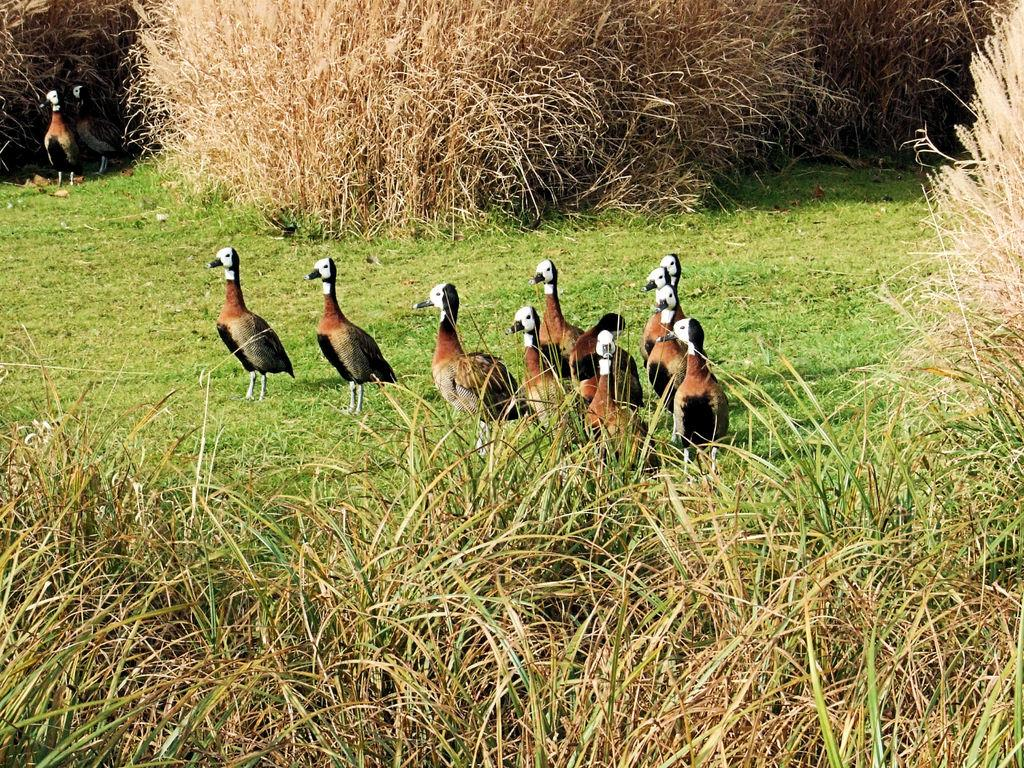What type of ground is in the center of the image? There is grass ground in the center of the image. What animals can be seen on the grass ground? There are birds standing on the grass ground. What type of vegetation is present in the front of the image? There are bushes in the front of the image. What type of vegetation is present in the background of the image? There are bushes in the background of the image. What type of lamp is being used by the mom in the image? There is no mom or lamp present in the image; it features grass ground, birds, and bushes. 